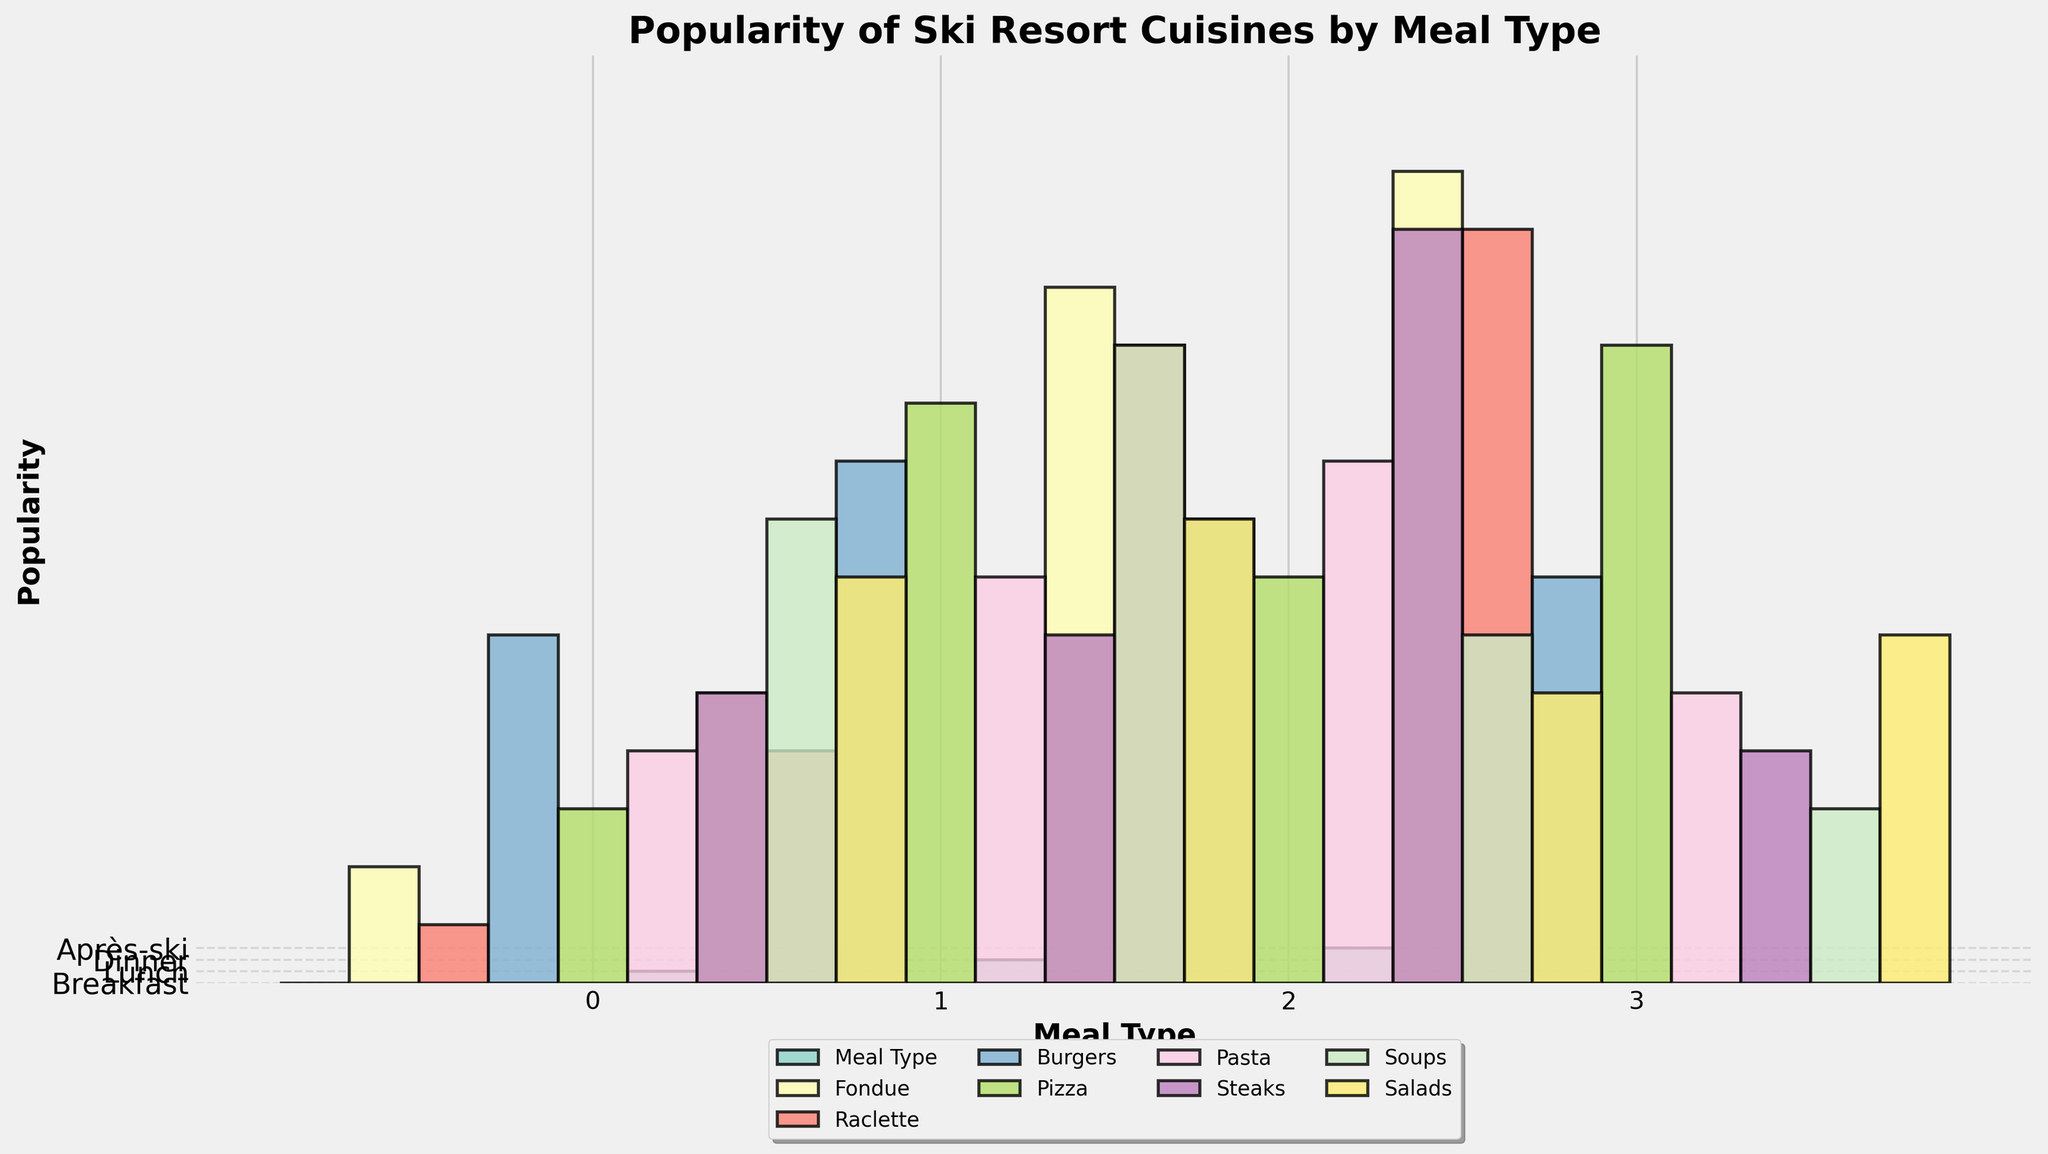What's the most popular cuisine for après-ski? From the chart, the bars for each cuisine at après-ski can be compared visually. Fondue has the tallest bar among them.
Answer: Fondue Which cuisine is more popular during lunch: pasta or steaks? Look at the bars for pasta and steaks under the lunch category. The bar for pasta is higher than the bar for steaks.
Answer: Pasta What is the total popularity of pizza across all meal types? Sum the heights of the pizza bars for breakfast, lunch, dinner, and après-ski. 15 (breakfast) + 50 (lunch) + 35 (dinner) + 55 (après-ski) = 155
Answer: 155 Which meal type has the lowest popularity for soups? Compare the heights of the bars representing soups for each meal type. The dinner bar for soups is the shortest.
Answer: Dinner How does the popularity of burgers during breakfast compare to their popularity during après-ski? Compare the height of the burger bar during breakfast (30) to that of après-ski (35). The breakfast bar is shorter.
Answer: Lower What's the difference in popularity between breakfast steaks and dinner steaks? Find the heights of the breakfast and dinner steaks bars (25 and 65, respectively) and calculate the difference: 65 - 25.
Answer: 40 What is the average popularity of raclette over all meal types? Sum the raclette bars for all meal types and divide by 4. (5 + 20 + 55 + 65) / 4 = 145 / 4 = 36.25
Answer: 36.25 Which cuisine appears to have the most consistent popularity across meal types? By visually inspecting the bars and noting the smallest variability in height across meal types, it appears that pasta has a fairly consistent popularity, without extreme highs or lows.
Answer: Pasta Compare the popularity of salads during lunch and après-ski. Which is higher? The height of the salad bar during lunch is 40, and during après-ski, it is 30. Therefore, lunch is higher.
Answer: Lunch What is the collective popularity of all cuisines for dinner? Sum the heights of all bars for the dinner meal type (Fondue: 60, Raclette: 55, Burgers: 40, Pizza: 35, Pasta: 45, Steaks: 65, Soups: 30, Salads: 25). 60 + 55 + 40 + 35 + 45 + 65 + 30 + 25 = 355
Answer: 355 